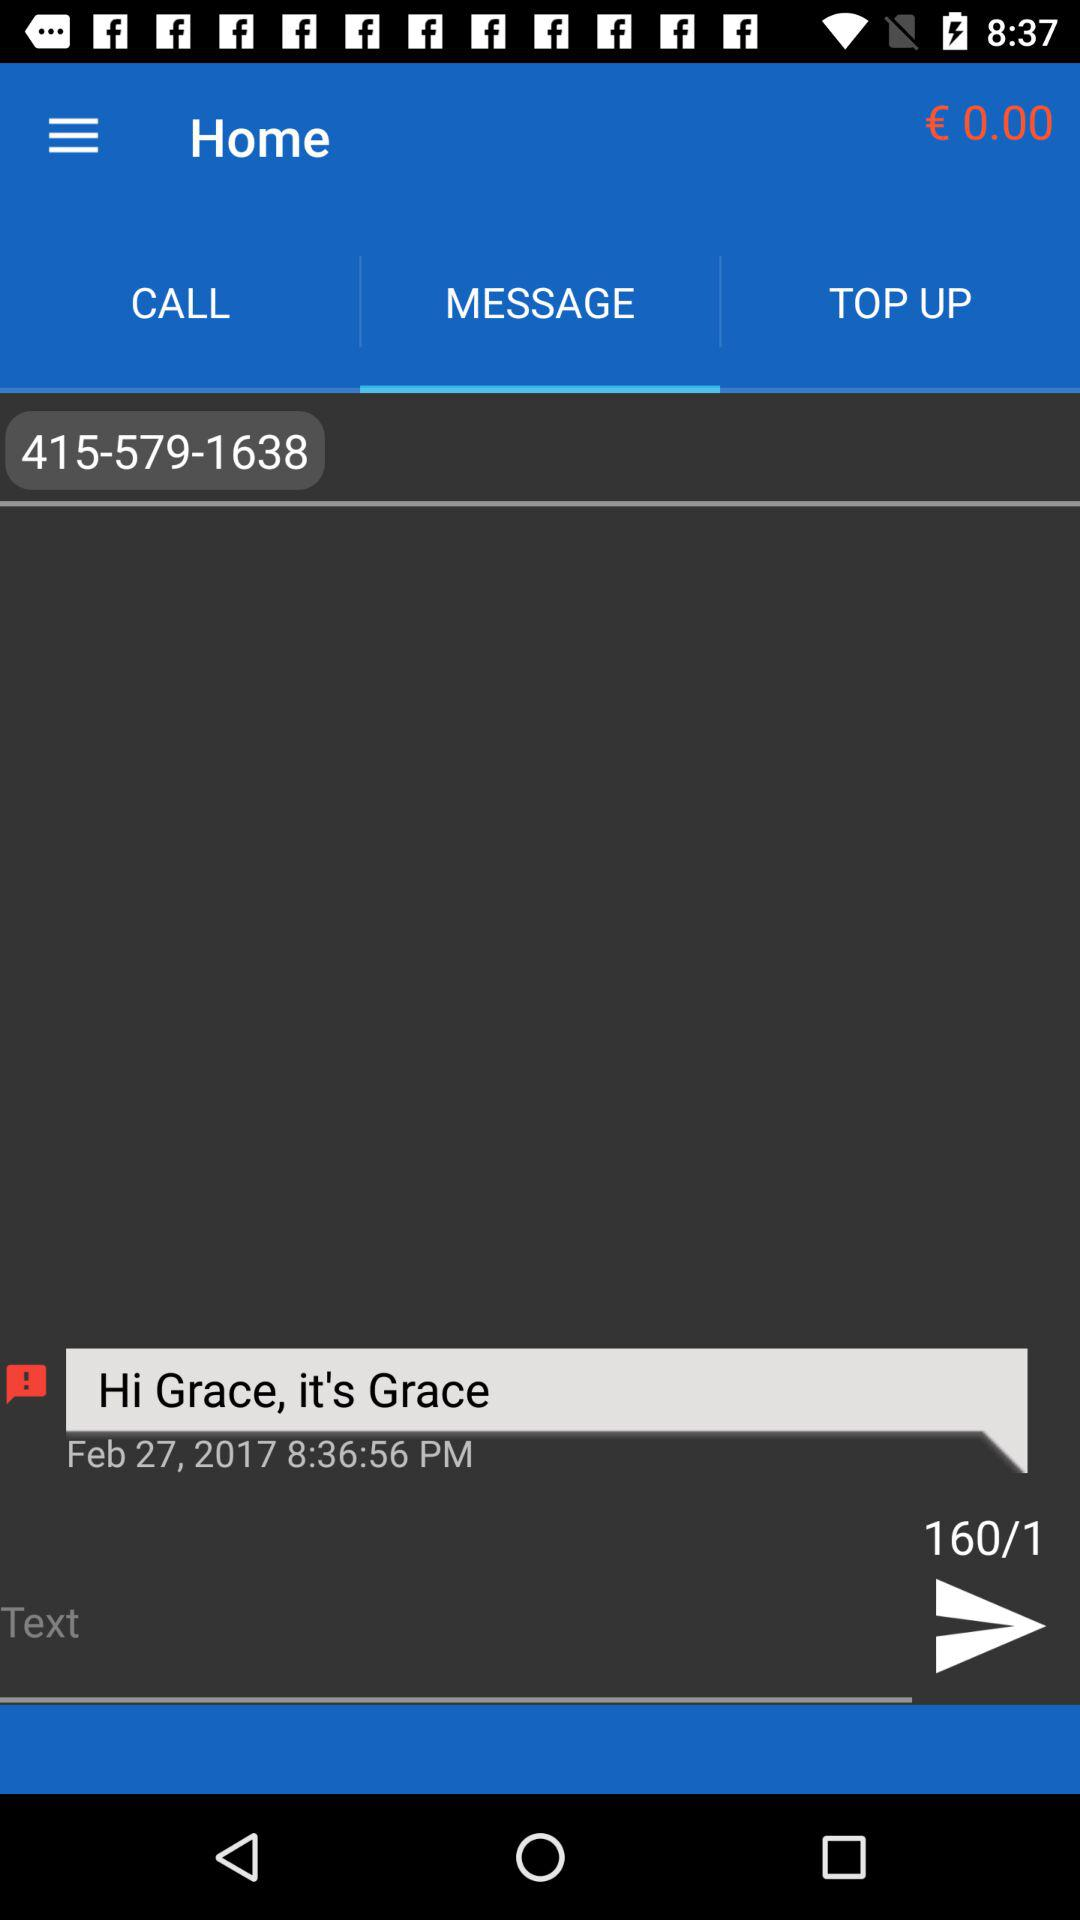Which tab is selected? The selected tab is "MESSAGE". 